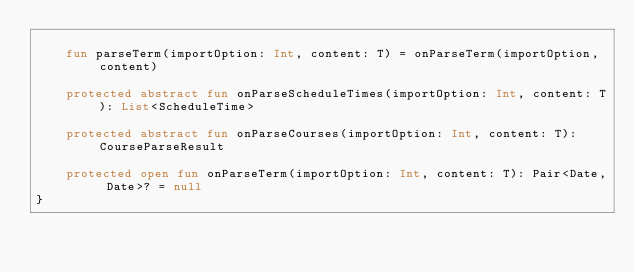Convert code to text. <code><loc_0><loc_0><loc_500><loc_500><_Kotlin_>
    fun parseTerm(importOption: Int, content: T) = onParseTerm(importOption, content)

    protected abstract fun onParseScheduleTimes(importOption: Int, content: T): List<ScheduleTime>

    protected abstract fun onParseCourses(importOption: Int, content: T): CourseParseResult

    protected open fun onParseTerm(importOption: Int, content: T): Pair<Date, Date>? = null
}</code> 